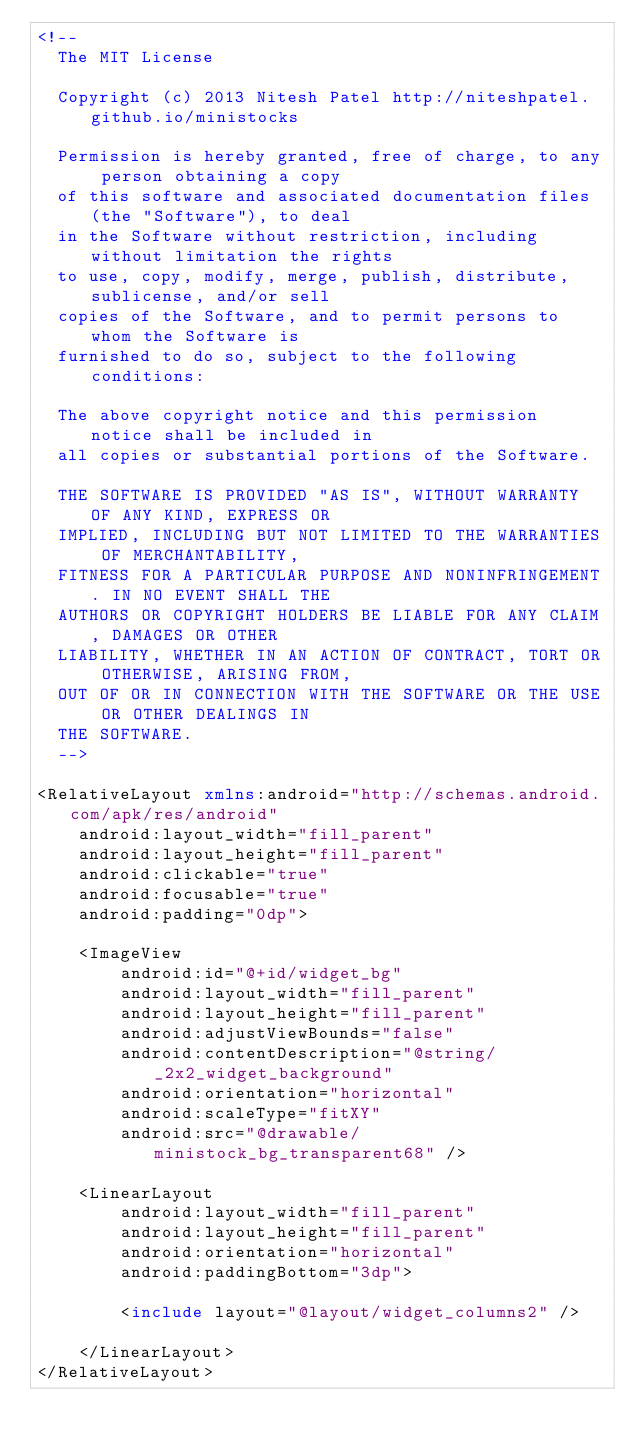<code> <loc_0><loc_0><loc_500><loc_500><_XML_><!--
  The MIT License

  Copyright (c) 2013 Nitesh Patel http://niteshpatel.github.io/ministocks

  Permission is hereby granted, free of charge, to any person obtaining a copy
  of this software and associated documentation files (the "Software"), to deal
  in the Software without restriction, including without limitation the rights
  to use, copy, modify, merge, publish, distribute, sublicense, and/or sell
  copies of the Software, and to permit persons to whom the Software is
  furnished to do so, subject to the following conditions:

  The above copyright notice and this permission notice shall be included in
  all copies or substantial portions of the Software.

  THE SOFTWARE IS PROVIDED "AS IS", WITHOUT WARRANTY OF ANY KIND, EXPRESS OR
  IMPLIED, INCLUDING BUT NOT LIMITED TO THE WARRANTIES OF MERCHANTABILITY,
  FITNESS FOR A PARTICULAR PURPOSE AND NONINFRINGEMENT. IN NO EVENT SHALL THE
  AUTHORS OR COPYRIGHT HOLDERS BE LIABLE FOR ANY CLAIM, DAMAGES OR OTHER
  LIABILITY, WHETHER IN AN ACTION OF CONTRACT, TORT OR OTHERWISE, ARISING FROM,
  OUT OF OR IN CONNECTION WITH THE SOFTWARE OR THE USE OR OTHER DEALINGS IN
  THE SOFTWARE.
  -->

<RelativeLayout xmlns:android="http://schemas.android.com/apk/res/android"
    android:layout_width="fill_parent"
    android:layout_height="fill_parent"
    android:clickable="true"
    android:focusable="true"
    android:padding="0dp">

    <ImageView
        android:id="@+id/widget_bg"
        android:layout_width="fill_parent"
        android:layout_height="fill_parent"
        android:adjustViewBounds="false"
        android:contentDescription="@string/_2x2_widget_background"
        android:orientation="horizontal"
        android:scaleType="fitXY"
        android:src="@drawable/ministock_bg_transparent68" />

    <LinearLayout
        android:layout_width="fill_parent"
        android:layout_height="fill_parent"
        android:orientation="horizontal"
        android:paddingBottom="3dp">

        <include layout="@layout/widget_columns2" />

    </LinearLayout>
</RelativeLayout>    
</code> 